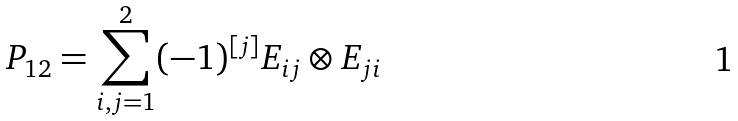Convert formula to latex. <formula><loc_0><loc_0><loc_500><loc_500>P _ { 1 2 } = \sum _ { i , j = 1 } ^ { 2 } ( - 1 ) ^ { [ j ] } E _ { i j } \otimes E _ { j i }</formula> 